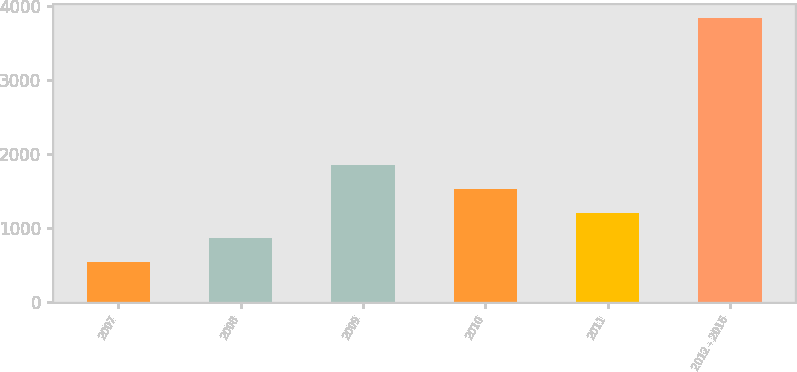Convert chart to OTSL. <chart><loc_0><loc_0><loc_500><loc_500><bar_chart><fcel>2007<fcel>2008<fcel>2009<fcel>2010<fcel>2011<fcel>2012 - 2016<nl><fcel>543<fcel>873<fcel>1863<fcel>1533<fcel>1203<fcel>3843<nl></chart> 